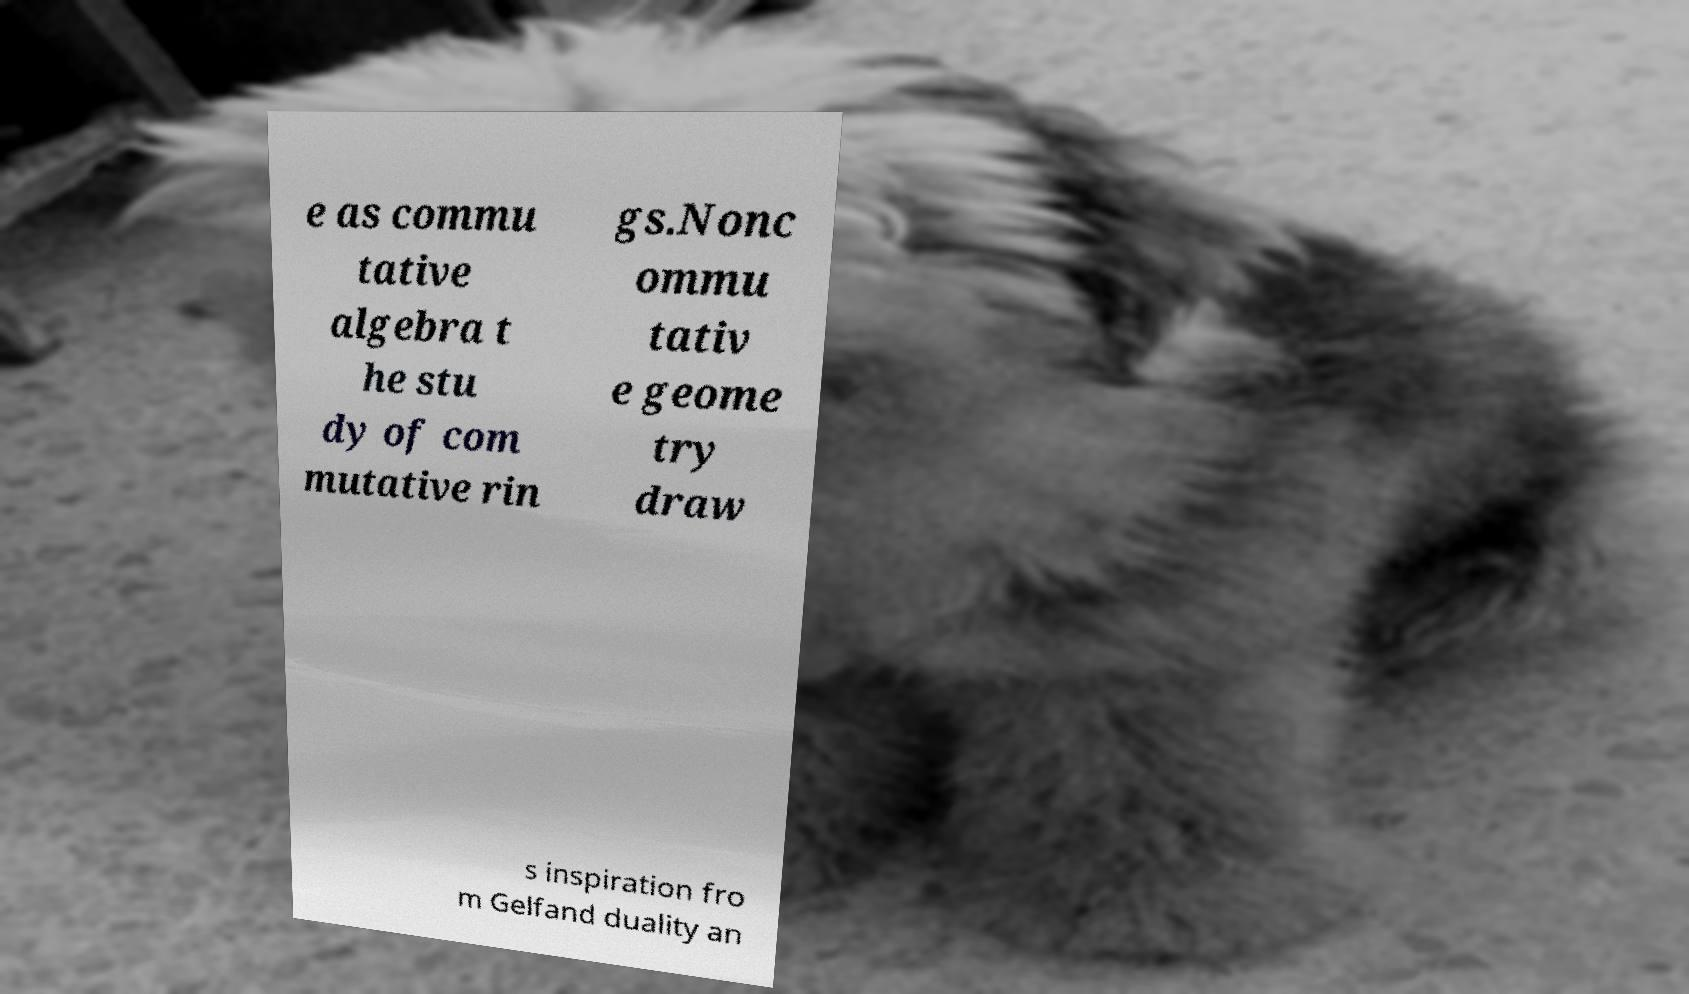Can you accurately transcribe the text from the provided image for me? e as commu tative algebra t he stu dy of com mutative rin gs.Nonc ommu tativ e geome try draw s inspiration fro m Gelfand duality an 